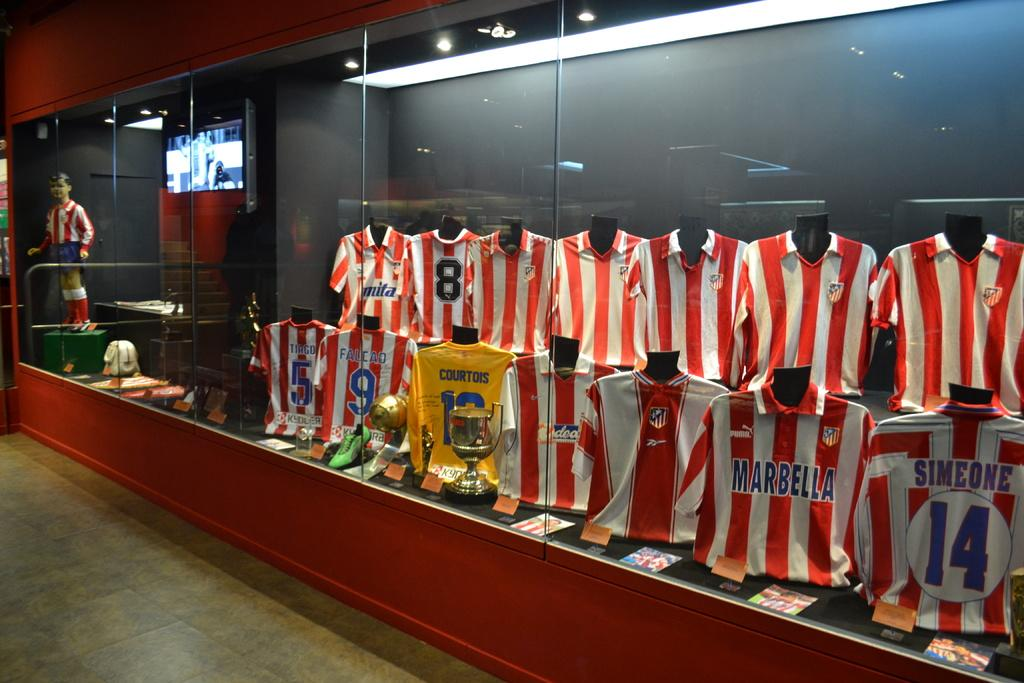<image>
Provide a brief description of the given image. A set of uniforms in a display case include Marabella's uniform. 